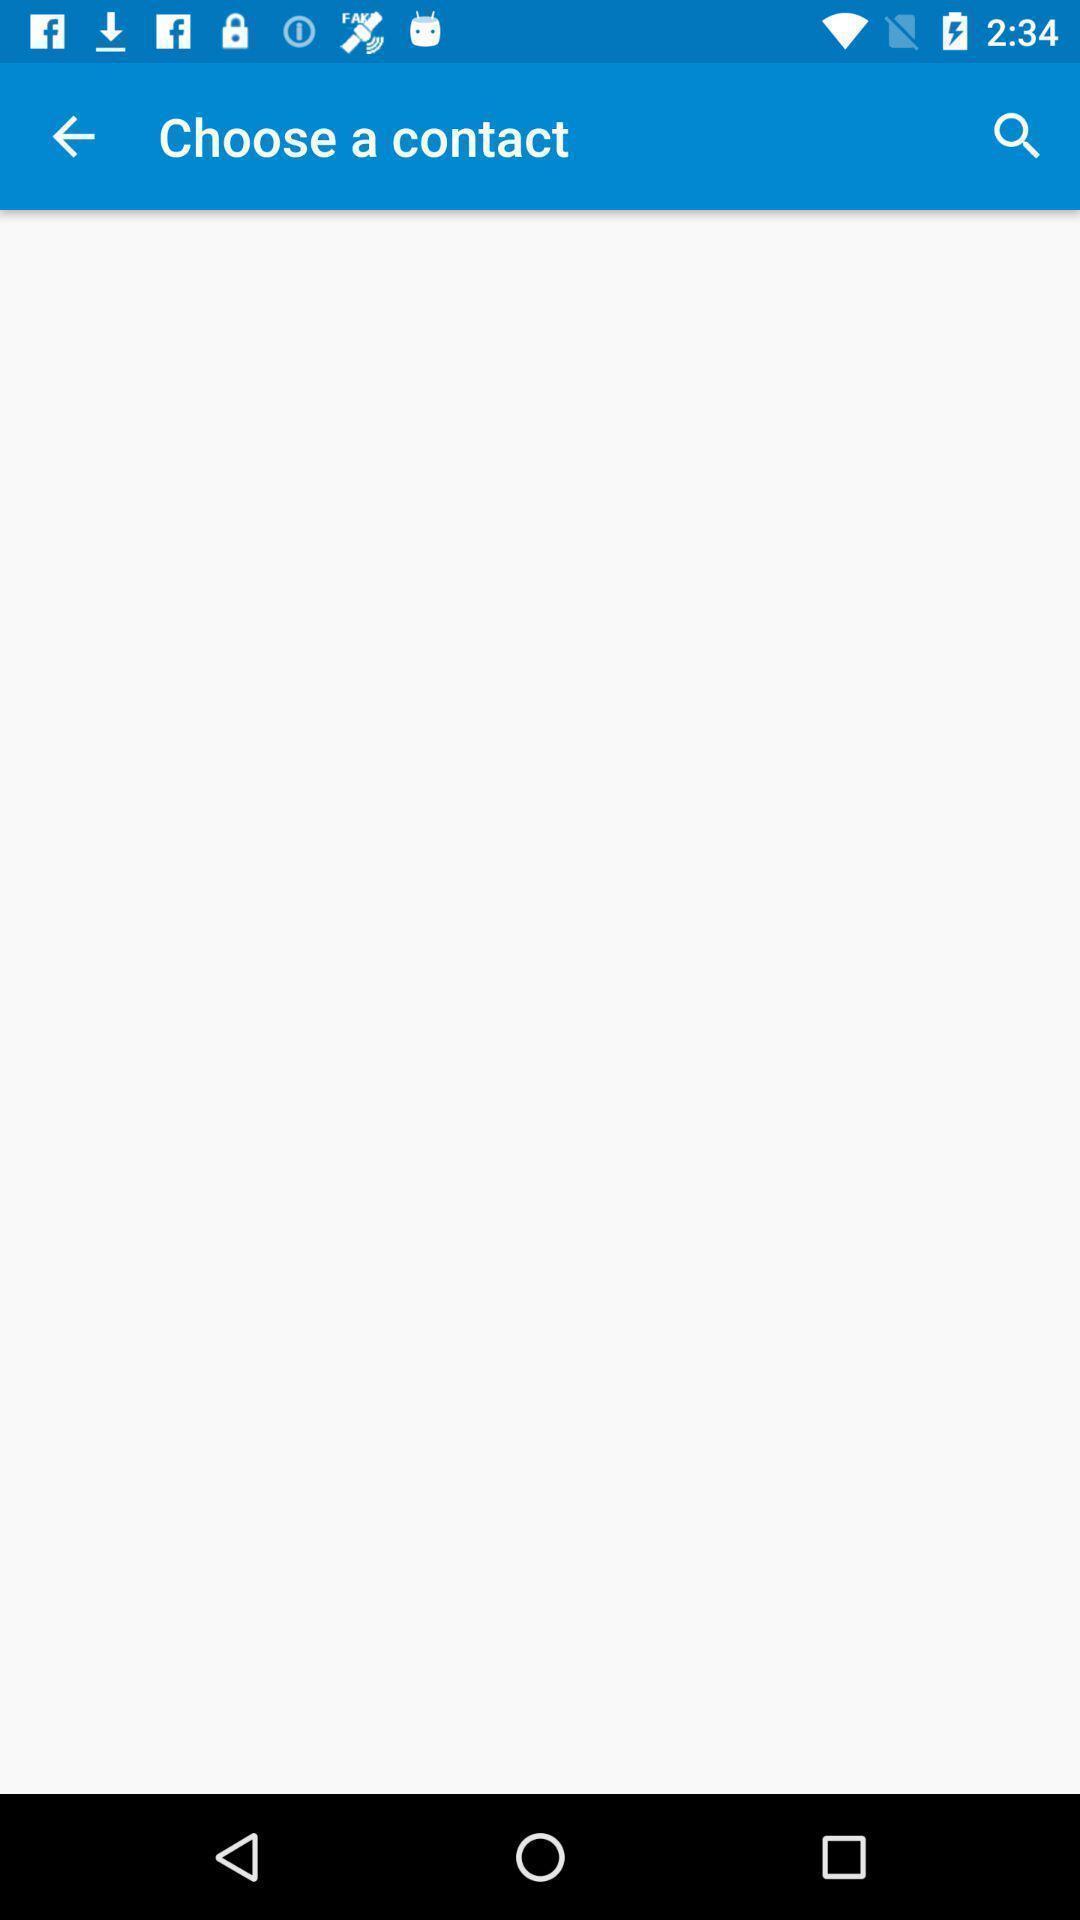Please provide a description for this image. Page displaying contacts page. 